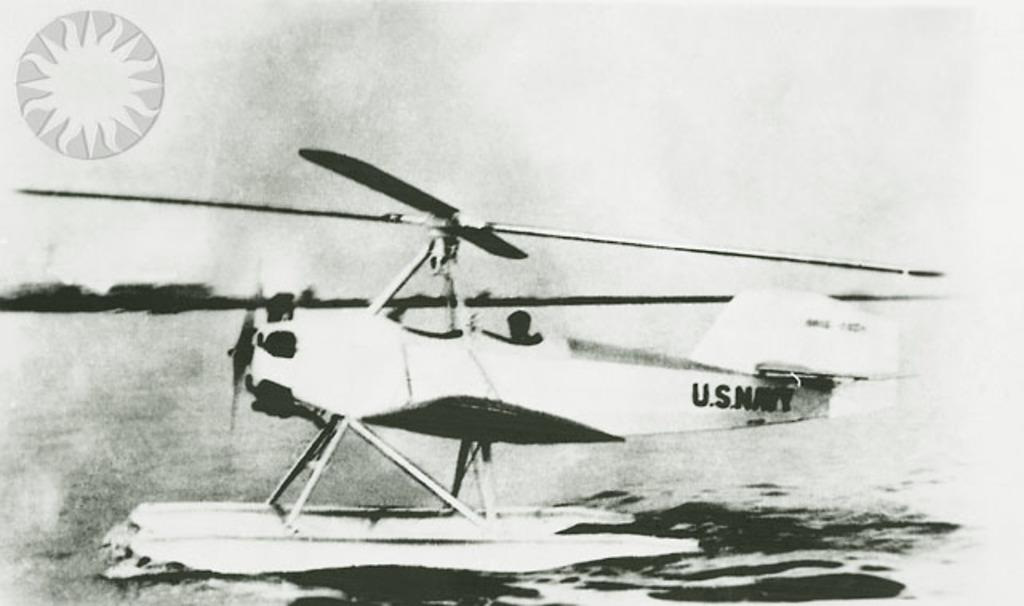<image>
Relay a brief, clear account of the picture shown. An old US Navy helicopter is sitting in the water. 